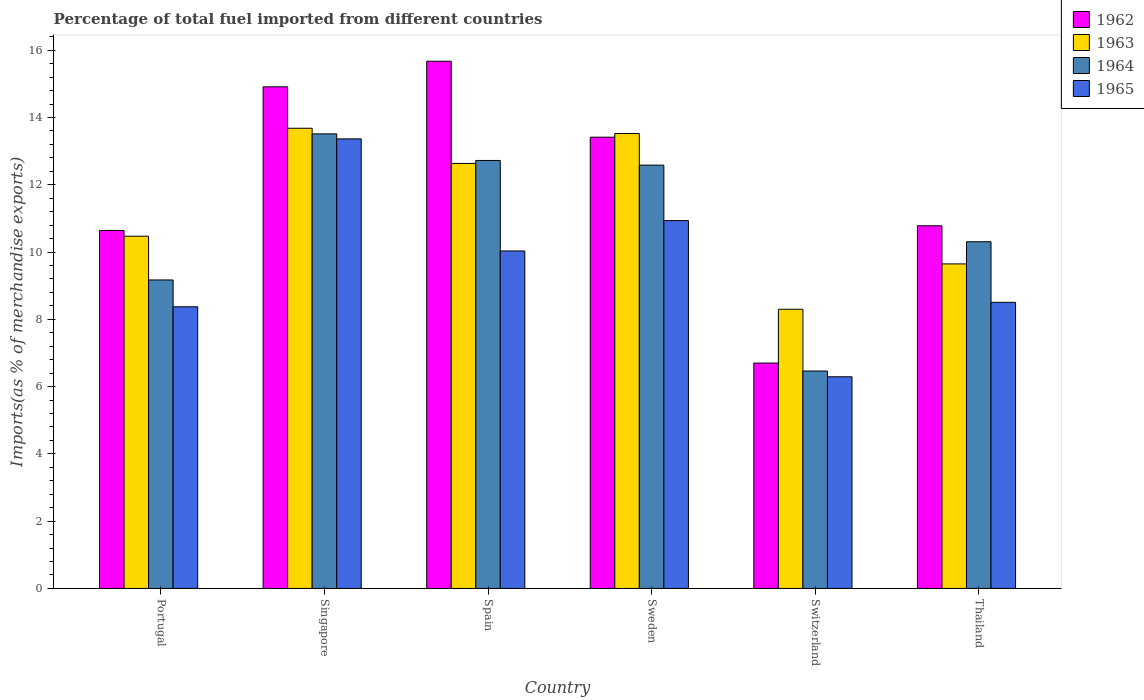How many different coloured bars are there?
Ensure brevity in your answer.  4. How many groups of bars are there?
Make the answer very short. 6. Are the number of bars per tick equal to the number of legend labels?
Ensure brevity in your answer.  Yes. Are the number of bars on each tick of the X-axis equal?
Ensure brevity in your answer.  Yes. What is the label of the 6th group of bars from the left?
Offer a terse response. Thailand. What is the percentage of imports to different countries in 1963 in Portugal?
Offer a very short reply. 10.47. Across all countries, what is the maximum percentage of imports to different countries in 1963?
Make the answer very short. 13.68. Across all countries, what is the minimum percentage of imports to different countries in 1963?
Your answer should be compact. 8.3. In which country was the percentage of imports to different countries in 1965 maximum?
Offer a very short reply. Singapore. In which country was the percentage of imports to different countries in 1964 minimum?
Make the answer very short. Switzerland. What is the total percentage of imports to different countries in 1963 in the graph?
Ensure brevity in your answer.  68.26. What is the difference between the percentage of imports to different countries in 1965 in Portugal and that in Spain?
Keep it short and to the point. -1.66. What is the difference between the percentage of imports to different countries in 1964 in Thailand and the percentage of imports to different countries in 1965 in Switzerland?
Provide a succinct answer. 4.01. What is the average percentage of imports to different countries in 1965 per country?
Your answer should be compact. 9.58. What is the difference between the percentage of imports to different countries of/in 1963 and percentage of imports to different countries of/in 1964 in Sweden?
Make the answer very short. 0.94. What is the ratio of the percentage of imports to different countries in 1962 in Portugal to that in Sweden?
Give a very brief answer. 0.79. Is the percentage of imports to different countries in 1962 in Spain less than that in Switzerland?
Your response must be concise. No. What is the difference between the highest and the second highest percentage of imports to different countries in 1965?
Provide a short and direct response. 0.9. What is the difference between the highest and the lowest percentage of imports to different countries in 1962?
Your answer should be very brief. 8.97. Is the sum of the percentage of imports to different countries in 1962 in Spain and Switzerland greater than the maximum percentage of imports to different countries in 1965 across all countries?
Your response must be concise. Yes. Is it the case that in every country, the sum of the percentage of imports to different countries in 1962 and percentage of imports to different countries in 1964 is greater than the sum of percentage of imports to different countries in 1963 and percentage of imports to different countries in 1965?
Give a very brief answer. No. What does the 3rd bar from the left in Switzerland represents?
Ensure brevity in your answer.  1964. What does the 4th bar from the right in Singapore represents?
Your response must be concise. 1962. How many bars are there?
Your answer should be very brief. 24. What is the difference between two consecutive major ticks on the Y-axis?
Make the answer very short. 2. Are the values on the major ticks of Y-axis written in scientific E-notation?
Provide a short and direct response. No. Does the graph contain any zero values?
Provide a succinct answer. No. Where does the legend appear in the graph?
Your answer should be very brief. Top right. How many legend labels are there?
Ensure brevity in your answer.  4. What is the title of the graph?
Provide a succinct answer. Percentage of total fuel imported from different countries. Does "2005" appear as one of the legend labels in the graph?
Offer a terse response. No. What is the label or title of the Y-axis?
Your response must be concise. Imports(as % of merchandise exports). What is the Imports(as % of merchandise exports) of 1962 in Portugal?
Your answer should be very brief. 10.64. What is the Imports(as % of merchandise exports) in 1963 in Portugal?
Your answer should be compact. 10.47. What is the Imports(as % of merchandise exports) in 1964 in Portugal?
Make the answer very short. 9.17. What is the Imports(as % of merchandise exports) of 1965 in Portugal?
Make the answer very short. 8.37. What is the Imports(as % of merchandise exports) of 1962 in Singapore?
Give a very brief answer. 14.91. What is the Imports(as % of merchandise exports) of 1963 in Singapore?
Ensure brevity in your answer.  13.68. What is the Imports(as % of merchandise exports) of 1964 in Singapore?
Provide a succinct answer. 13.51. What is the Imports(as % of merchandise exports) in 1965 in Singapore?
Your response must be concise. 13.37. What is the Imports(as % of merchandise exports) in 1962 in Spain?
Your response must be concise. 15.67. What is the Imports(as % of merchandise exports) of 1963 in Spain?
Give a very brief answer. 12.64. What is the Imports(as % of merchandise exports) in 1964 in Spain?
Your response must be concise. 12.72. What is the Imports(as % of merchandise exports) of 1965 in Spain?
Ensure brevity in your answer.  10.03. What is the Imports(as % of merchandise exports) in 1962 in Sweden?
Keep it short and to the point. 13.42. What is the Imports(as % of merchandise exports) of 1963 in Sweden?
Ensure brevity in your answer.  13.52. What is the Imports(as % of merchandise exports) of 1964 in Sweden?
Your response must be concise. 12.58. What is the Imports(as % of merchandise exports) of 1965 in Sweden?
Give a very brief answer. 10.93. What is the Imports(as % of merchandise exports) of 1962 in Switzerland?
Make the answer very short. 6.7. What is the Imports(as % of merchandise exports) of 1963 in Switzerland?
Your answer should be compact. 8.3. What is the Imports(as % of merchandise exports) of 1964 in Switzerland?
Give a very brief answer. 6.46. What is the Imports(as % of merchandise exports) in 1965 in Switzerland?
Give a very brief answer. 6.29. What is the Imports(as % of merchandise exports) in 1962 in Thailand?
Make the answer very short. 10.78. What is the Imports(as % of merchandise exports) of 1963 in Thailand?
Keep it short and to the point. 9.65. What is the Imports(as % of merchandise exports) in 1964 in Thailand?
Your answer should be compact. 10.31. What is the Imports(as % of merchandise exports) of 1965 in Thailand?
Your response must be concise. 8.51. Across all countries, what is the maximum Imports(as % of merchandise exports) in 1962?
Offer a very short reply. 15.67. Across all countries, what is the maximum Imports(as % of merchandise exports) in 1963?
Make the answer very short. 13.68. Across all countries, what is the maximum Imports(as % of merchandise exports) in 1964?
Provide a short and direct response. 13.51. Across all countries, what is the maximum Imports(as % of merchandise exports) of 1965?
Your answer should be very brief. 13.37. Across all countries, what is the minimum Imports(as % of merchandise exports) in 1962?
Ensure brevity in your answer.  6.7. Across all countries, what is the minimum Imports(as % of merchandise exports) of 1963?
Your answer should be compact. 8.3. Across all countries, what is the minimum Imports(as % of merchandise exports) in 1964?
Offer a terse response. 6.46. Across all countries, what is the minimum Imports(as % of merchandise exports) of 1965?
Your answer should be very brief. 6.29. What is the total Imports(as % of merchandise exports) of 1962 in the graph?
Your answer should be very brief. 72.13. What is the total Imports(as % of merchandise exports) in 1963 in the graph?
Your response must be concise. 68.26. What is the total Imports(as % of merchandise exports) in 1964 in the graph?
Your response must be concise. 64.76. What is the total Imports(as % of merchandise exports) in 1965 in the graph?
Offer a terse response. 57.51. What is the difference between the Imports(as % of merchandise exports) in 1962 in Portugal and that in Singapore?
Make the answer very short. -4.27. What is the difference between the Imports(as % of merchandise exports) in 1963 in Portugal and that in Singapore?
Your response must be concise. -3.21. What is the difference between the Imports(as % of merchandise exports) of 1964 in Portugal and that in Singapore?
Offer a very short reply. -4.34. What is the difference between the Imports(as % of merchandise exports) of 1965 in Portugal and that in Singapore?
Offer a terse response. -4.99. What is the difference between the Imports(as % of merchandise exports) of 1962 in Portugal and that in Spain?
Your answer should be compact. -5.03. What is the difference between the Imports(as % of merchandise exports) of 1963 in Portugal and that in Spain?
Offer a terse response. -2.16. What is the difference between the Imports(as % of merchandise exports) of 1964 in Portugal and that in Spain?
Offer a very short reply. -3.55. What is the difference between the Imports(as % of merchandise exports) in 1965 in Portugal and that in Spain?
Offer a terse response. -1.66. What is the difference between the Imports(as % of merchandise exports) in 1962 in Portugal and that in Sweden?
Give a very brief answer. -2.77. What is the difference between the Imports(as % of merchandise exports) in 1963 in Portugal and that in Sweden?
Keep it short and to the point. -3.05. What is the difference between the Imports(as % of merchandise exports) of 1964 in Portugal and that in Sweden?
Offer a terse response. -3.41. What is the difference between the Imports(as % of merchandise exports) of 1965 in Portugal and that in Sweden?
Ensure brevity in your answer.  -2.56. What is the difference between the Imports(as % of merchandise exports) of 1962 in Portugal and that in Switzerland?
Your response must be concise. 3.94. What is the difference between the Imports(as % of merchandise exports) in 1963 in Portugal and that in Switzerland?
Your answer should be very brief. 2.17. What is the difference between the Imports(as % of merchandise exports) of 1964 in Portugal and that in Switzerland?
Your answer should be very brief. 2.71. What is the difference between the Imports(as % of merchandise exports) of 1965 in Portugal and that in Switzerland?
Your answer should be compact. 2.08. What is the difference between the Imports(as % of merchandise exports) of 1962 in Portugal and that in Thailand?
Offer a terse response. -0.14. What is the difference between the Imports(as % of merchandise exports) in 1963 in Portugal and that in Thailand?
Provide a succinct answer. 0.82. What is the difference between the Imports(as % of merchandise exports) in 1964 in Portugal and that in Thailand?
Offer a very short reply. -1.14. What is the difference between the Imports(as % of merchandise exports) of 1965 in Portugal and that in Thailand?
Provide a succinct answer. -0.13. What is the difference between the Imports(as % of merchandise exports) of 1962 in Singapore and that in Spain?
Your response must be concise. -0.76. What is the difference between the Imports(as % of merchandise exports) in 1963 in Singapore and that in Spain?
Provide a short and direct response. 1.05. What is the difference between the Imports(as % of merchandise exports) of 1964 in Singapore and that in Spain?
Provide a succinct answer. 0.79. What is the difference between the Imports(as % of merchandise exports) in 1965 in Singapore and that in Spain?
Provide a succinct answer. 3.33. What is the difference between the Imports(as % of merchandise exports) of 1962 in Singapore and that in Sweden?
Offer a terse response. 1.5. What is the difference between the Imports(as % of merchandise exports) in 1963 in Singapore and that in Sweden?
Your answer should be compact. 0.16. What is the difference between the Imports(as % of merchandise exports) in 1964 in Singapore and that in Sweden?
Give a very brief answer. 0.93. What is the difference between the Imports(as % of merchandise exports) of 1965 in Singapore and that in Sweden?
Keep it short and to the point. 2.43. What is the difference between the Imports(as % of merchandise exports) of 1962 in Singapore and that in Switzerland?
Offer a very short reply. 8.21. What is the difference between the Imports(as % of merchandise exports) of 1963 in Singapore and that in Switzerland?
Keep it short and to the point. 5.38. What is the difference between the Imports(as % of merchandise exports) in 1964 in Singapore and that in Switzerland?
Make the answer very short. 7.05. What is the difference between the Imports(as % of merchandise exports) in 1965 in Singapore and that in Switzerland?
Your response must be concise. 7.07. What is the difference between the Imports(as % of merchandise exports) of 1962 in Singapore and that in Thailand?
Ensure brevity in your answer.  4.13. What is the difference between the Imports(as % of merchandise exports) in 1963 in Singapore and that in Thailand?
Provide a succinct answer. 4.03. What is the difference between the Imports(as % of merchandise exports) in 1964 in Singapore and that in Thailand?
Your response must be concise. 3.21. What is the difference between the Imports(as % of merchandise exports) in 1965 in Singapore and that in Thailand?
Provide a short and direct response. 4.86. What is the difference between the Imports(as % of merchandise exports) of 1962 in Spain and that in Sweden?
Your answer should be compact. 2.26. What is the difference between the Imports(as % of merchandise exports) of 1963 in Spain and that in Sweden?
Your answer should be very brief. -0.89. What is the difference between the Imports(as % of merchandise exports) in 1964 in Spain and that in Sweden?
Ensure brevity in your answer.  0.14. What is the difference between the Imports(as % of merchandise exports) in 1965 in Spain and that in Sweden?
Keep it short and to the point. -0.9. What is the difference between the Imports(as % of merchandise exports) in 1962 in Spain and that in Switzerland?
Keep it short and to the point. 8.97. What is the difference between the Imports(as % of merchandise exports) in 1963 in Spain and that in Switzerland?
Provide a succinct answer. 4.34. What is the difference between the Imports(as % of merchandise exports) of 1964 in Spain and that in Switzerland?
Your answer should be compact. 6.26. What is the difference between the Imports(as % of merchandise exports) of 1965 in Spain and that in Switzerland?
Ensure brevity in your answer.  3.74. What is the difference between the Imports(as % of merchandise exports) in 1962 in Spain and that in Thailand?
Your answer should be very brief. 4.89. What is the difference between the Imports(as % of merchandise exports) in 1963 in Spain and that in Thailand?
Provide a short and direct response. 2.99. What is the difference between the Imports(as % of merchandise exports) of 1964 in Spain and that in Thailand?
Offer a terse response. 2.42. What is the difference between the Imports(as % of merchandise exports) of 1965 in Spain and that in Thailand?
Offer a terse response. 1.53. What is the difference between the Imports(as % of merchandise exports) of 1962 in Sweden and that in Switzerland?
Keep it short and to the point. 6.72. What is the difference between the Imports(as % of merchandise exports) of 1963 in Sweden and that in Switzerland?
Keep it short and to the point. 5.22. What is the difference between the Imports(as % of merchandise exports) of 1964 in Sweden and that in Switzerland?
Give a very brief answer. 6.12. What is the difference between the Imports(as % of merchandise exports) in 1965 in Sweden and that in Switzerland?
Ensure brevity in your answer.  4.64. What is the difference between the Imports(as % of merchandise exports) of 1962 in Sweden and that in Thailand?
Give a very brief answer. 2.63. What is the difference between the Imports(as % of merchandise exports) of 1963 in Sweden and that in Thailand?
Provide a short and direct response. 3.88. What is the difference between the Imports(as % of merchandise exports) in 1964 in Sweden and that in Thailand?
Offer a terse response. 2.28. What is the difference between the Imports(as % of merchandise exports) in 1965 in Sweden and that in Thailand?
Your response must be concise. 2.43. What is the difference between the Imports(as % of merchandise exports) of 1962 in Switzerland and that in Thailand?
Offer a terse response. -4.08. What is the difference between the Imports(as % of merchandise exports) of 1963 in Switzerland and that in Thailand?
Ensure brevity in your answer.  -1.35. What is the difference between the Imports(as % of merchandise exports) of 1964 in Switzerland and that in Thailand?
Your response must be concise. -3.84. What is the difference between the Imports(as % of merchandise exports) of 1965 in Switzerland and that in Thailand?
Provide a short and direct response. -2.21. What is the difference between the Imports(as % of merchandise exports) of 1962 in Portugal and the Imports(as % of merchandise exports) of 1963 in Singapore?
Provide a succinct answer. -3.04. What is the difference between the Imports(as % of merchandise exports) of 1962 in Portugal and the Imports(as % of merchandise exports) of 1964 in Singapore?
Provide a succinct answer. -2.87. What is the difference between the Imports(as % of merchandise exports) of 1962 in Portugal and the Imports(as % of merchandise exports) of 1965 in Singapore?
Provide a succinct answer. -2.72. What is the difference between the Imports(as % of merchandise exports) in 1963 in Portugal and the Imports(as % of merchandise exports) in 1964 in Singapore?
Offer a terse response. -3.04. What is the difference between the Imports(as % of merchandise exports) in 1963 in Portugal and the Imports(as % of merchandise exports) in 1965 in Singapore?
Your answer should be very brief. -2.89. What is the difference between the Imports(as % of merchandise exports) in 1964 in Portugal and the Imports(as % of merchandise exports) in 1965 in Singapore?
Make the answer very short. -4.19. What is the difference between the Imports(as % of merchandise exports) in 1962 in Portugal and the Imports(as % of merchandise exports) in 1963 in Spain?
Your answer should be very brief. -1.99. What is the difference between the Imports(as % of merchandise exports) of 1962 in Portugal and the Imports(as % of merchandise exports) of 1964 in Spain?
Provide a short and direct response. -2.08. What is the difference between the Imports(as % of merchandise exports) of 1962 in Portugal and the Imports(as % of merchandise exports) of 1965 in Spain?
Give a very brief answer. 0.61. What is the difference between the Imports(as % of merchandise exports) in 1963 in Portugal and the Imports(as % of merchandise exports) in 1964 in Spain?
Make the answer very short. -2.25. What is the difference between the Imports(as % of merchandise exports) of 1963 in Portugal and the Imports(as % of merchandise exports) of 1965 in Spain?
Your answer should be very brief. 0.44. What is the difference between the Imports(as % of merchandise exports) of 1964 in Portugal and the Imports(as % of merchandise exports) of 1965 in Spain?
Make the answer very short. -0.86. What is the difference between the Imports(as % of merchandise exports) in 1962 in Portugal and the Imports(as % of merchandise exports) in 1963 in Sweden?
Your answer should be very brief. -2.88. What is the difference between the Imports(as % of merchandise exports) in 1962 in Portugal and the Imports(as % of merchandise exports) in 1964 in Sweden?
Make the answer very short. -1.94. What is the difference between the Imports(as % of merchandise exports) in 1962 in Portugal and the Imports(as % of merchandise exports) in 1965 in Sweden?
Your response must be concise. -0.29. What is the difference between the Imports(as % of merchandise exports) in 1963 in Portugal and the Imports(as % of merchandise exports) in 1964 in Sweden?
Make the answer very short. -2.11. What is the difference between the Imports(as % of merchandise exports) in 1963 in Portugal and the Imports(as % of merchandise exports) in 1965 in Sweden?
Keep it short and to the point. -0.46. What is the difference between the Imports(as % of merchandise exports) in 1964 in Portugal and the Imports(as % of merchandise exports) in 1965 in Sweden?
Provide a short and direct response. -1.76. What is the difference between the Imports(as % of merchandise exports) of 1962 in Portugal and the Imports(as % of merchandise exports) of 1963 in Switzerland?
Your answer should be very brief. 2.34. What is the difference between the Imports(as % of merchandise exports) in 1962 in Portugal and the Imports(as % of merchandise exports) in 1964 in Switzerland?
Offer a terse response. 4.18. What is the difference between the Imports(as % of merchandise exports) in 1962 in Portugal and the Imports(as % of merchandise exports) in 1965 in Switzerland?
Provide a succinct answer. 4.35. What is the difference between the Imports(as % of merchandise exports) in 1963 in Portugal and the Imports(as % of merchandise exports) in 1964 in Switzerland?
Your answer should be very brief. 4.01. What is the difference between the Imports(as % of merchandise exports) in 1963 in Portugal and the Imports(as % of merchandise exports) in 1965 in Switzerland?
Give a very brief answer. 4.18. What is the difference between the Imports(as % of merchandise exports) of 1964 in Portugal and the Imports(as % of merchandise exports) of 1965 in Switzerland?
Give a very brief answer. 2.88. What is the difference between the Imports(as % of merchandise exports) of 1962 in Portugal and the Imports(as % of merchandise exports) of 1963 in Thailand?
Offer a very short reply. 0.99. What is the difference between the Imports(as % of merchandise exports) of 1962 in Portugal and the Imports(as % of merchandise exports) of 1964 in Thailand?
Your response must be concise. 0.33. What is the difference between the Imports(as % of merchandise exports) in 1962 in Portugal and the Imports(as % of merchandise exports) in 1965 in Thailand?
Give a very brief answer. 2.14. What is the difference between the Imports(as % of merchandise exports) in 1963 in Portugal and the Imports(as % of merchandise exports) in 1964 in Thailand?
Your answer should be very brief. 0.17. What is the difference between the Imports(as % of merchandise exports) of 1963 in Portugal and the Imports(as % of merchandise exports) of 1965 in Thailand?
Ensure brevity in your answer.  1.97. What is the difference between the Imports(as % of merchandise exports) in 1964 in Portugal and the Imports(as % of merchandise exports) in 1965 in Thailand?
Your response must be concise. 0.66. What is the difference between the Imports(as % of merchandise exports) of 1962 in Singapore and the Imports(as % of merchandise exports) of 1963 in Spain?
Offer a terse response. 2.28. What is the difference between the Imports(as % of merchandise exports) in 1962 in Singapore and the Imports(as % of merchandise exports) in 1964 in Spain?
Offer a very short reply. 2.19. What is the difference between the Imports(as % of merchandise exports) in 1962 in Singapore and the Imports(as % of merchandise exports) in 1965 in Spain?
Provide a short and direct response. 4.88. What is the difference between the Imports(as % of merchandise exports) in 1963 in Singapore and the Imports(as % of merchandise exports) in 1964 in Spain?
Keep it short and to the point. 0.96. What is the difference between the Imports(as % of merchandise exports) in 1963 in Singapore and the Imports(as % of merchandise exports) in 1965 in Spain?
Your answer should be very brief. 3.65. What is the difference between the Imports(as % of merchandise exports) of 1964 in Singapore and the Imports(as % of merchandise exports) of 1965 in Spain?
Offer a terse response. 3.48. What is the difference between the Imports(as % of merchandise exports) of 1962 in Singapore and the Imports(as % of merchandise exports) of 1963 in Sweden?
Your answer should be very brief. 1.39. What is the difference between the Imports(as % of merchandise exports) of 1962 in Singapore and the Imports(as % of merchandise exports) of 1964 in Sweden?
Your answer should be compact. 2.33. What is the difference between the Imports(as % of merchandise exports) in 1962 in Singapore and the Imports(as % of merchandise exports) in 1965 in Sweden?
Give a very brief answer. 3.98. What is the difference between the Imports(as % of merchandise exports) of 1963 in Singapore and the Imports(as % of merchandise exports) of 1964 in Sweden?
Offer a very short reply. 1.1. What is the difference between the Imports(as % of merchandise exports) in 1963 in Singapore and the Imports(as % of merchandise exports) in 1965 in Sweden?
Ensure brevity in your answer.  2.75. What is the difference between the Imports(as % of merchandise exports) in 1964 in Singapore and the Imports(as % of merchandise exports) in 1965 in Sweden?
Your response must be concise. 2.58. What is the difference between the Imports(as % of merchandise exports) in 1962 in Singapore and the Imports(as % of merchandise exports) in 1963 in Switzerland?
Offer a very short reply. 6.61. What is the difference between the Imports(as % of merchandise exports) of 1962 in Singapore and the Imports(as % of merchandise exports) of 1964 in Switzerland?
Make the answer very short. 8.45. What is the difference between the Imports(as % of merchandise exports) in 1962 in Singapore and the Imports(as % of merchandise exports) in 1965 in Switzerland?
Your response must be concise. 8.62. What is the difference between the Imports(as % of merchandise exports) of 1963 in Singapore and the Imports(as % of merchandise exports) of 1964 in Switzerland?
Your response must be concise. 7.22. What is the difference between the Imports(as % of merchandise exports) of 1963 in Singapore and the Imports(as % of merchandise exports) of 1965 in Switzerland?
Make the answer very short. 7.39. What is the difference between the Imports(as % of merchandise exports) in 1964 in Singapore and the Imports(as % of merchandise exports) in 1965 in Switzerland?
Your answer should be compact. 7.22. What is the difference between the Imports(as % of merchandise exports) of 1962 in Singapore and the Imports(as % of merchandise exports) of 1963 in Thailand?
Provide a short and direct response. 5.27. What is the difference between the Imports(as % of merchandise exports) of 1962 in Singapore and the Imports(as % of merchandise exports) of 1964 in Thailand?
Your answer should be very brief. 4.61. What is the difference between the Imports(as % of merchandise exports) of 1962 in Singapore and the Imports(as % of merchandise exports) of 1965 in Thailand?
Your answer should be very brief. 6.41. What is the difference between the Imports(as % of merchandise exports) of 1963 in Singapore and the Imports(as % of merchandise exports) of 1964 in Thailand?
Your response must be concise. 3.37. What is the difference between the Imports(as % of merchandise exports) in 1963 in Singapore and the Imports(as % of merchandise exports) in 1965 in Thailand?
Your answer should be very brief. 5.18. What is the difference between the Imports(as % of merchandise exports) in 1964 in Singapore and the Imports(as % of merchandise exports) in 1965 in Thailand?
Make the answer very short. 5.01. What is the difference between the Imports(as % of merchandise exports) of 1962 in Spain and the Imports(as % of merchandise exports) of 1963 in Sweden?
Ensure brevity in your answer.  2.15. What is the difference between the Imports(as % of merchandise exports) of 1962 in Spain and the Imports(as % of merchandise exports) of 1964 in Sweden?
Your answer should be very brief. 3.09. What is the difference between the Imports(as % of merchandise exports) of 1962 in Spain and the Imports(as % of merchandise exports) of 1965 in Sweden?
Provide a succinct answer. 4.74. What is the difference between the Imports(as % of merchandise exports) of 1963 in Spain and the Imports(as % of merchandise exports) of 1964 in Sweden?
Offer a terse response. 0.05. What is the difference between the Imports(as % of merchandise exports) in 1963 in Spain and the Imports(as % of merchandise exports) in 1965 in Sweden?
Make the answer very short. 1.7. What is the difference between the Imports(as % of merchandise exports) in 1964 in Spain and the Imports(as % of merchandise exports) in 1965 in Sweden?
Keep it short and to the point. 1.79. What is the difference between the Imports(as % of merchandise exports) in 1962 in Spain and the Imports(as % of merchandise exports) in 1963 in Switzerland?
Your answer should be compact. 7.37. What is the difference between the Imports(as % of merchandise exports) of 1962 in Spain and the Imports(as % of merchandise exports) of 1964 in Switzerland?
Give a very brief answer. 9.21. What is the difference between the Imports(as % of merchandise exports) in 1962 in Spain and the Imports(as % of merchandise exports) in 1965 in Switzerland?
Offer a very short reply. 9.38. What is the difference between the Imports(as % of merchandise exports) of 1963 in Spain and the Imports(as % of merchandise exports) of 1964 in Switzerland?
Provide a short and direct response. 6.17. What is the difference between the Imports(as % of merchandise exports) of 1963 in Spain and the Imports(as % of merchandise exports) of 1965 in Switzerland?
Your response must be concise. 6.34. What is the difference between the Imports(as % of merchandise exports) of 1964 in Spain and the Imports(as % of merchandise exports) of 1965 in Switzerland?
Provide a succinct answer. 6.43. What is the difference between the Imports(as % of merchandise exports) in 1962 in Spain and the Imports(as % of merchandise exports) in 1963 in Thailand?
Ensure brevity in your answer.  6.03. What is the difference between the Imports(as % of merchandise exports) of 1962 in Spain and the Imports(as % of merchandise exports) of 1964 in Thailand?
Give a very brief answer. 5.37. What is the difference between the Imports(as % of merchandise exports) of 1962 in Spain and the Imports(as % of merchandise exports) of 1965 in Thailand?
Ensure brevity in your answer.  7.17. What is the difference between the Imports(as % of merchandise exports) of 1963 in Spain and the Imports(as % of merchandise exports) of 1964 in Thailand?
Provide a succinct answer. 2.33. What is the difference between the Imports(as % of merchandise exports) in 1963 in Spain and the Imports(as % of merchandise exports) in 1965 in Thailand?
Offer a terse response. 4.13. What is the difference between the Imports(as % of merchandise exports) in 1964 in Spain and the Imports(as % of merchandise exports) in 1965 in Thailand?
Your response must be concise. 4.22. What is the difference between the Imports(as % of merchandise exports) of 1962 in Sweden and the Imports(as % of merchandise exports) of 1963 in Switzerland?
Provide a succinct answer. 5.12. What is the difference between the Imports(as % of merchandise exports) in 1962 in Sweden and the Imports(as % of merchandise exports) in 1964 in Switzerland?
Keep it short and to the point. 6.95. What is the difference between the Imports(as % of merchandise exports) of 1962 in Sweden and the Imports(as % of merchandise exports) of 1965 in Switzerland?
Ensure brevity in your answer.  7.12. What is the difference between the Imports(as % of merchandise exports) of 1963 in Sweden and the Imports(as % of merchandise exports) of 1964 in Switzerland?
Provide a succinct answer. 7.06. What is the difference between the Imports(as % of merchandise exports) of 1963 in Sweden and the Imports(as % of merchandise exports) of 1965 in Switzerland?
Your answer should be very brief. 7.23. What is the difference between the Imports(as % of merchandise exports) of 1964 in Sweden and the Imports(as % of merchandise exports) of 1965 in Switzerland?
Make the answer very short. 6.29. What is the difference between the Imports(as % of merchandise exports) of 1962 in Sweden and the Imports(as % of merchandise exports) of 1963 in Thailand?
Offer a very short reply. 3.77. What is the difference between the Imports(as % of merchandise exports) of 1962 in Sweden and the Imports(as % of merchandise exports) of 1964 in Thailand?
Give a very brief answer. 3.11. What is the difference between the Imports(as % of merchandise exports) in 1962 in Sweden and the Imports(as % of merchandise exports) in 1965 in Thailand?
Your answer should be compact. 4.91. What is the difference between the Imports(as % of merchandise exports) in 1963 in Sweden and the Imports(as % of merchandise exports) in 1964 in Thailand?
Provide a succinct answer. 3.22. What is the difference between the Imports(as % of merchandise exports) of 1963 in Sweden and the Imports(as % of merchandise exports) of 1965 in Thailand?
Your response must be concise. 5.02. What is the difference between the Imports(as % of merchandise exports) in 1964 in Sweden and the Imports(as % of merchandise exports) in 1965 in Thailand?
Give a very brief answer. 4.08. What is the difference between the Imports(as % of merchandise exports) in 1962 in Switzerland and the Imports(as % of merchandise exports) in 1963 in Thailand?
Provide a succinct answer. -2.95. What is the difference between the Imports(as % of merchandise exports) in 1962 in Switzerland and the Imports(as % of merchandise exports) in 1964 in Thailand?
Give a very brief answer. -3.61. What is the difference between the Imports(as % of merchandise exports) of 1962 in Switzerland and the Imports(as % of merchandise exports) of 1965 in Thailand?
Give a very brief answer. -1.81. What is the difference between the Imports(as % of merchandise exports) in 1963 in Switzerland and the Imports(as % of merchandise exports) in 1964 in Thailand?
Make the answer very short. -2.01. What is the difference between the Imports(as % of merchandise exports) of 1963 in Switzerland and the Imports(as % of merchandise exports) of 1965 in Thailand?
Offer a terse response. -0.21. What is the difference between the Imports(as % of merchandise exports) of 1964 in Switzerland and the Imports(as % of merchandise exports) of 1965 in Thailand?
Provide a succinct answer. -2.04. What is the average Imports(as % of merchandise exports) in 1962 per country?
Ensure brevity in your answer.  12.02. What is the average Imports(as % of merchandise exports) in 1963 per country?
Ensure brevity in your answer.  11.38. What is the average Imports(as % of merchandise exports) in 1964 per country?
Give a very brief answer. 10.79. What is the average Imports(as % of merchandise exports) of 1965 per country?
Keep it short and to the point. 9.58. What is the difference between the Imports(as % of merchandise exports) of 1962 and Imports(as % of merchandise exports) of 1963 in Portugal?
Your answer should be compact. 0.17. What is the difference between the Imports(as % of merchandise exports) of 1962 and Imports(as % of merchandise exports) of 1964 in Portugal?
Your answer should be compact. 1.47. What is the difference between the Imports(as % of merchandise exports) of 1962 and Imports(as % of merchandise exports) of 1965 in Portugal?
Ensure brevity in your answer.  2.27. What is the difference between the Imports(as % of merchandise exports) in 1963 and Imports(as % of merchandise exports) in 1964 in Portugal?
Ensure brevity in your answer.  1.3. What is the difference between the Imports(as % of merchandise exports) in 1963 and Imports(as % of merchandise exports) in 1965 in Portugal?
Provide a short and direct response. 2.1. What is the difference between the Imports(as % of merchandise exports) of 1964 and Imports(as % of merchandise exports) of 1965 in Portugal?
Give a very brief answer. 0.8. What is the difference between the Imports(as % of merchandise exports) of 1962 and Imports(as % of merchandise exports) of 1963 in Singapore?
Give a very brief answer. 1.23. What is the difference between the Imports(as % of merchandise exports) in 1962 and Imports(as % of merchandise exports) in 1964 in Singapore?
Offer a terse response. 1.4. What is the difference between the Imports(as % of merchandise exports) of 1962 and Imports(as % of merchandise exports) of 1965 in Singapore?
Your answer should be compact. 1.55. What is the difference between the Imports(as % of merchandise exports) in 1963 and Imports(as % of merchandise exports) in 1964 in Singapore?
Your response must be concise. 0.17. What is the difference between the Imports(as % of merchandise exports) in 1963 and Imports(as % of merchandise exports) in 1965 in Singapore?
Provide a short and direct response. 0.32. What is the difference between the Imports(as % of merchandise exports) of 1964 and Imports(as % of merchandise exports) of 1965 in Singapore?
Provide a short and direct response. 0.15. What is the difference between the Imports(as % of merchandise exports) in 1962 and Imports(as % of merchandise exports) in 1963 in Spain?
Make the answer very short. 3.04. What is the difference between the Imports(as % of merchandise exports) in 1962 and Imports(as % of merchandise exports) in 1964 in Spain?
Keep it short and to the point. 2.95. What is the difference between the Imports(as % of merchandise exports) in 1962 and Imports(as % of merchandise exports) in 1965 in Spain?
Your answer should be compact. 5.64. What is the difference between the Imports(as % of merchandise exports) of 1963 and Imports(as % of merchandise exports) of 1964 in Spain?
Your response must be concise. -0.09. What is the difference between the Imports(as % of merchandise exports) of 1963 and Imports(as % of merchandise exports) of 1965 in Spain?
Offer a very short reply. 2.6. What is the difference between the Imports(as % of merchandise exports) in 1964 and Imports(as % of merchandise exports) in 1965 in Spain?
Offer a terse response. 2.69. What is the difference between the Imports(as % of merchandise exports) of 1962 and Imports(as % of merchandise exports) of 1963 in Sweden?
Your answer should be compact. -0.11. What is the difference between the Imports(as % of merchandise exports) in 1962 and Imports(as % of merchandise exports) in 1964 in Sweden?
Your response must be concise. 0.83. What is the difference between the Imports(as % of merchandise exports) of 1962 and Imports(as % of merchandise exports) of 1965 in Sweden?
Provide a short and direct response. 2.48. What is the difference between the Imports(as % of merchandise exports) of 1963 and Imports(as % of merchandise exports) of 1964 in Sweden?
Keep it short and to the point. 0.94. What is the difference between the Imports(as % of merchandise exports) in 1963 and Imports(as % of merchandise exports) in 1965 in Sweden?
Offer a terse response. 2.59. What is the difference between the Imports(as % of merchandise exports) in 1964 and Imports(as % of merchandise exports) in 1965 in Sweden?
Provide a succinct answer. 1.65. What is the difference between the Imports(as % of merchandise exports) in 1962 and Imports(as % of merchandise exports) in 1963 in Switzerland?
Provide a succinct answer. -1.6. What is the difference between the Imports(as % of merchandise exports) in 1962 and Imports(as % of merchandise exports) in 1964 in Switzerland?
Your answer should be very brief. 0.24. What is the difference between the Imports(as % of merchandise exports) of 1962 and Imports(as % of merchandise exports) of 1965 in Switzerland?
Give a very brief answer. 0.41. What is the difference between the Imports(as % of merchandise exports) of 1963 and Imports(as % of merchandise exports) of 1964 in Switzerland?
Offer a terse response. 1.84. What is the difference between the Imports(as % of merchandise exports) in 1963 and Imports(as % of merchandise exports) in 1965 in Switzerland?
Give a very brief answer. 2.01. What is the difference between the Imports(as % of merchandise exports) of 1964 and Imports(as % of merchandise exports) of 1965 in Switzerland?
Offer a terse response. 0.17. What is the difference between the Imports(as % of merchandise exports) of 1962 and Imports(as % of merchandise exports) of 1963 in Thailand?
Make the answer very short. 1.13. What is the difference between the Imports(as % of merchandise exports) of 1962 and Imports(as % of merchandise exports) of 1964 in Thailand?
Give a very brief answer. 0.48. What is the difference between the Imports(as % of merchandise exports) of 1962 and Imports(as % of merchandise exports) of 1965 in Thailand?
Make the answer very short. 2.28. What is the difference between the Imports(as % of merchandise exports) in 1963 and Imports(as % of merchandise exports) in 1964 in Thailand?
Your answer should be very brief. -0.66. What is the difference between the Imports(as % of merchandise exports) of 1963 and Imports(as % of merchandise exports) of 1965 in Thailand?
Offer a very short reply. 1.14. What is the difference between the Imports(as % of merchandise exports) in 1964 and Imports(as % of merchandise exports) in 1965 in Thailand?
Make the answer very short. 1.8. What is the ratio of the Imports(as % of merchandise exports) of 1962 in Portugal to that in Singapore?
Offer a terse response. 0.71. What is the ratio of the Imports(as % of merchandise exports) in 1963 in Portugal to that in Singapore?
Ensure brevity in your answer.  0.77. What is the ratio of the Imports(as % of merchandise exports) in 1964 in Portugal to that in Singapore?
Provide a short and direct response. 0.68. What is the ratio of the Imports(as % of merchandise exports) in 1965 in Portugal to that in Singapore?
Provide a short and direct response. 0.63. What is the ratio of the Imports(as % of merchandise exports) in 1962 in Portugal to that in Spain?
Make the answer very short. 0.68. What is the ratio of the Imports(as % of merchandise exports) in 1963 in Portugal to that in Spain?
Give a very brief answer. 0.83. What is the ratio of the Imports(as % of merchandise exports) of 1964 in Portugal to that in Spain?
Provide a succinct answer. 0.72. What is the ratio of the Imports(as % of merchandise exports) of 1965 in Portugal to that in Spain?
Provide a short and direct response. 0.83. What is the ratio of the Imports(as % of merchandise exports) in 1962 in Portugal to that in Sweden?
Provide a succinct answer. 0.79. What is the ratio of the Imports(as % of merchandise exports) in 1963 in Portugal to that in Sweden?
Your answer should be compact. 0.77. What is the ratio of the Imports(as % of merchandise exports) in 1964 in Portugal to that in Sweden?
Provide a short and direct response. 0.73. What is the ratio of the Imports(as % of merchandise exports) of 1965 in Portugal to that in Sweden?
Offer a very short reply. 0.77. What is the ratio of the Imports(as % of merchandise exports) of 1962 in Portugal to that in Switzerland?
Make the answer very short. 1.59. What is the ratio of the Imports(as % of merchandise exports) of 1963 in Portugal to that in Switzerland?
Your answer should be compact. 1.26. What is the ratio of the Imports(as % of merchandise exports) of 1964 in Portugal to that in Switzerland?
Provide a short and direct response. 1.42. What is the ratio of the Imports(as % of merchandise exports) of 1965 in Portugal to that in Switzerland?
Give a very brief answer. 1.33. What is the ratio of the Imports(as % of merchandise exports) in 1963 in Portugal to that in Thailand?
Offer a terse response. 1.09. What is the ratio of the Imports(as % of merchandise exports) in 1964 in Portugal to that in Thailand?
Your response must be concise. 0.89. What is the ratio of the Imports(as % of merchandise exports) of 1965 in Portugal to that in Thailand?
Offer a very short reply. 0.98. What is the ratio of the Imports(as % of merchandise exports) of 1962 in Singapore to that in Spain?
Keep it short and to the point. 0.95. What is the ratio of the Imports(as % of merchandise exports) in 1963 in Singapore to that in Spain?
Your answer should be compact. 1.08. What is the ratio of the Imports(as % of merchandise exports) in 1964 in Singapore to that in Spain?
Your answer should be very brief. 1.06. What is the ratio of the Imports(as % of merchandise exports) in 1965 in Singapore to that in Spain?
Your response must be concise. 1.33. What is the ratio of the Imports(as % of merchandise exports) in 1962 in Singapore to that in Sweden?
Your answer should be compact. 1.11. What is the ratio of the Imports(as % of merchandise exports) of 1963 in Singapore to that in Sweden?
Provide a short and direct response. 1.01. What is the ratio of the Imports(as % of merchandise exports) in 1964 in Singapore to that in Sweden?
Your response must be concise. 1.07. What is the ratio of the Imports(as % of merchandise exports) of 1965 in Singapore to that in Sweden?
Your answer should be very brief. 1.22. What is the ratio of the Imports(as % of merchandise exports) in 1962 in Singapore to that in Switzerland?
Your response must be concise. 2.23. What is the ratio of the Imports(as % of merchandise exports) of 1963 in Singapore to that in Switzerland?
Your response must be concise. 1.65. What is the ratio of the Imports(as % of merchandise exports) of 1964 in Singapore to that in Switzerland?
Offer a very short reply. 2.09. What is the ratio of the Imports(as % of merchandise exports) of 1965 in Singapore to that in Switzerland?
Offer a very short reply. 2.12. What is the ratio of the Imports(as % of merchandise exports) of 1962 in Singapore to that in Thailand?
Give a very brief answer. 1.38. What is the ratio of the Imports(as % of merchandise exports) of 1963 in Singapore to that in Thailand?
Your answer should be compact. 1.42. What is the ratio of the Imports(as % of merchandise exports) of 1964 in Singapore to that in Thailand?
Your response must be concise. 1.31. What is the ratio of the Imports(as % of merchandise exports) of 1965 in Singapore to that in Thailand?
Give a very brief answer. 1.57. What is the ratio of the Imports(as % of merchandise exports) of 1962 in Spain to that in Sweden?
Provide a succinct answer. 1.17. What is the ratio of the Imports(as % of merchandise exports) in 1963 in Spain to that in Sweden?
Make the answer very short. 0.93. What is the ratio of the Imports(as % of merchandise exports) of 1965 in Spain to that in Sweden?
Keep it short and to the point. 0.92. What is the ratio of the Imports(as % of merchandise exports) of 1962 in Spain to that in Switzerland?
Your answer should be compact. 2.34. What is the ratio of the Imports(as % of merchandise exports) in 1963 in Spain to that in Switzerland?
Provide a short and direct response. 1.52. What is the ratio of the Imports(as % of merchandise exports) in 1964 in Spain to that in Switzerland?
Give a very brief answer. 1.97. What is the ratio of the Imports(as % of merchandise exports) in 1965 in Spain to that in Switzerland?
Provide a short and direct response. 1.59. What is the ratio of the Imports(as % of merchandise exports) of 1962 in Spain to that in Thailand?
Keep it short and to the point. 1.45. What is the ratio of the Imports(as % of merchandise exports) in 1963 in Spain to that in Thailand?
Your answer should be compact. 1.31. What is the ratio of the Imports(as % of merchandise exports) of 1964 in Spain to that in Thailand?
Make the answer very short. 1.23. What is the ratio of the Imports(as % of merchandise exports) of 1965 in Spain to that in Thailand?
Offer a terse response. 1.18. What is the ratio of the Imports(as % of merchandise exports) in 1962 in Sweden to that in Switzerland?
Offer a very short reply. 2. What is the ratio of the Imports(as % of merchandise exports) of 1963 in Sweden to that in Switzerland?
Keep it short and to the point. 1.63. What is the ratio of the Imports(as % of merchandise exports) of 1964 in Sweden to that in Switzerland?
Ensure brevity in your answer.  1.95. What is the ratio of the Imports(as % of merchandise exports) of 1965 in Sweden to that in Switzerland?
Make the answer very short. 1.74. What is the ratio of the Imports(as % of merchandise exports) in 1962 in Sweden to that in Thailand?
Your answer should be compact. 1.24. What is the ratio of the Imports(as % of merchandise exports) in 1963 in Sweden to that in Thailand?
Your answer should be compact. 1.4. What is the ratio of the Imports(as % of merchandise exports) in 1964 in Sweden to that in Thailand?
Ensure brevity in your answer.  1.22. What is the ratio of the Imports(as % of merchandise exports) of 1965 in Sweden to that in Thailand?
Your answer should be very brief. 1.29. What is the ratio of the Imports(as % of merchandise exports) in 1962 in Switzerland to that in Thailand?
Provide a succinct answer. 0.62. What is the ratio of the Imports(as % of merchandise exports) of 1963 in Switzerland to that in Thailand?
Keep it short and to the point. 0.86. What is the ratio of the Imports(as % of merchandise exports) of 1964 in Switzerland to that in Thailand?
Make the answer very short. 0.63. What is the ratio of the Imports(as % of merchandise exports) in 1965 in Switzerland to that in Thailand?
Ensure brevity in your answer.  0.74. What is the difference between the highest and the second highest Imports(as % of merchandise exports) in 1962?
Give a very brief answer. 0.76. What is the difference between the highest and the second highest Imports(as % of merchandise exports) in 1963?
Offer a terse response. 0.16. What is the difference between the highest and the second highest Imports(as % of merchandise exports) of 1964?
Your response must be concise. 0.79. What is the difference between the highest and the second highest Imports(as % of merchandise exports) of 1965?
Your answer should be very brief. 2.43. What is the difference between the highest and the lowest Imports(as % of merchandise exports) of 1962?
Provide a short and direct response. 8.97. What is the difference between the highest and the lowest Imports(as % of merchandise exports) of 1963?
Your answer should be very brief. 5.38. What is the difference between the highest and the lowest Imports(as % of merchandise exports) in 1964?
Ensure brevity in your answer.  7.05. What is the difference between the highest and the lowest Imports(as % of merchandise exports) in 1965?
Your answer should be very brief. 7.07. 